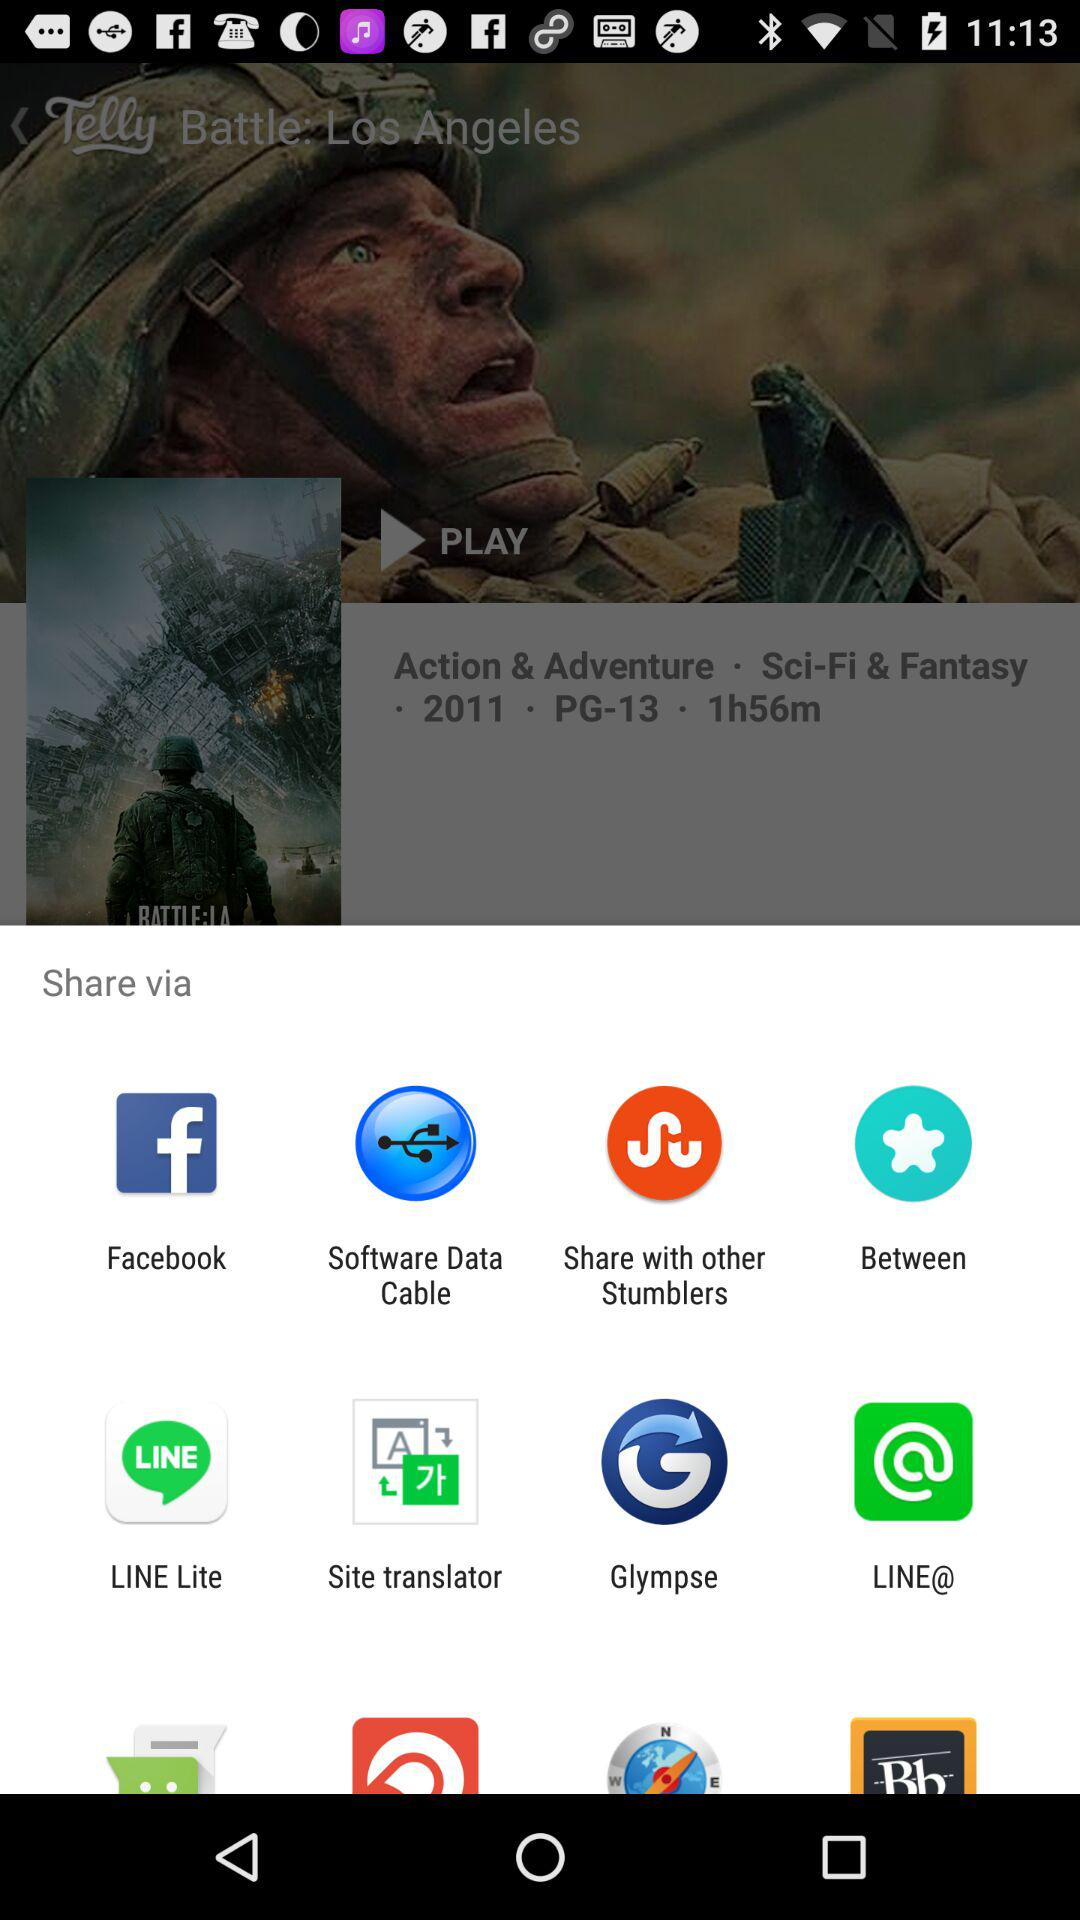What are the different options available for sharing? The different available options are "Facebook", "Software Data Cable", "Share with other Stumblers", "Between", "LINE Lite", "Site translator", "Glympse" and "LINE@". 